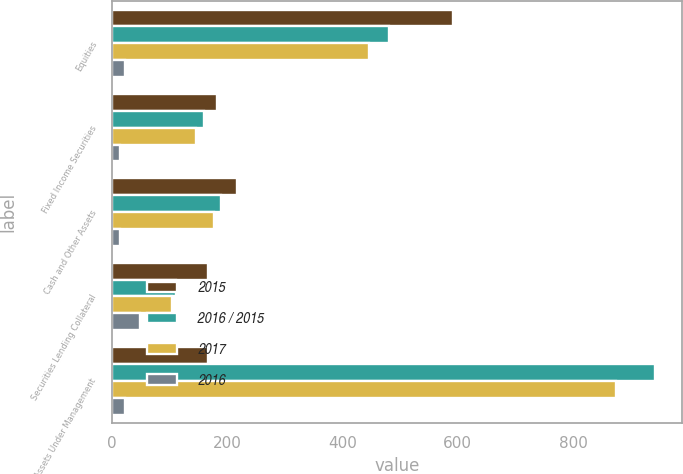Convert chart to OTSL. <chart><loc_0><loc_0><loc_500><loc_500><stacked_bar_chart><ecel><fcel>Equities<fcel>Fixed Income Securities<fcel>Cash and Other Assets<fcel>Securities Lending Collateral<fcel>Total Assets Under Management<nl><fcel>2015<fcel>592.3<fcel>183.5<fcel>217.5<fcel>167.7<fcel>167.7<nl><fcel>2016 / 2015<fcel>480.6<fcel>160.5<fcel>189.3<fcel>112<fcel>942.4<nl><fcel>2017<fcel>446.6<fcel>147.1<fcel>177.7<fcel>103.9<fcel>875.3<nl><fcel>2016<fcel>23<fcel>14<fcel>15<fcel>50<fcel>23<nl></chart> 